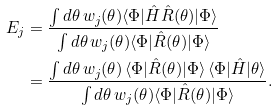<formula> <loc_0><loc_0><loc_500><loc_500>E _ { j } & = \frac { \int d \theta \, w _ { j } ( \theta ) \langle \Phi | \hat { H } \hat { R } ( \theta ) | \Phi \rangle } { \int d \theta \, w _ { j } ( \theta ) \langle \Phi | \hat { R } ( \theta ) | \Phi \rangle } \\ & = \frac { \int d \theta \, w _ { j } ( \theta ) \, \langle \Phi | \hat { R } ( \theta ) | \Phi \rangle \, \langle \Phi | \hat { H } | \theta \rangle } { \int d \theta \, w _ { j } ( \theta ) \langle \Phi | \hat { R } ( \theta ) | \Phi \rangle } .</formula> 